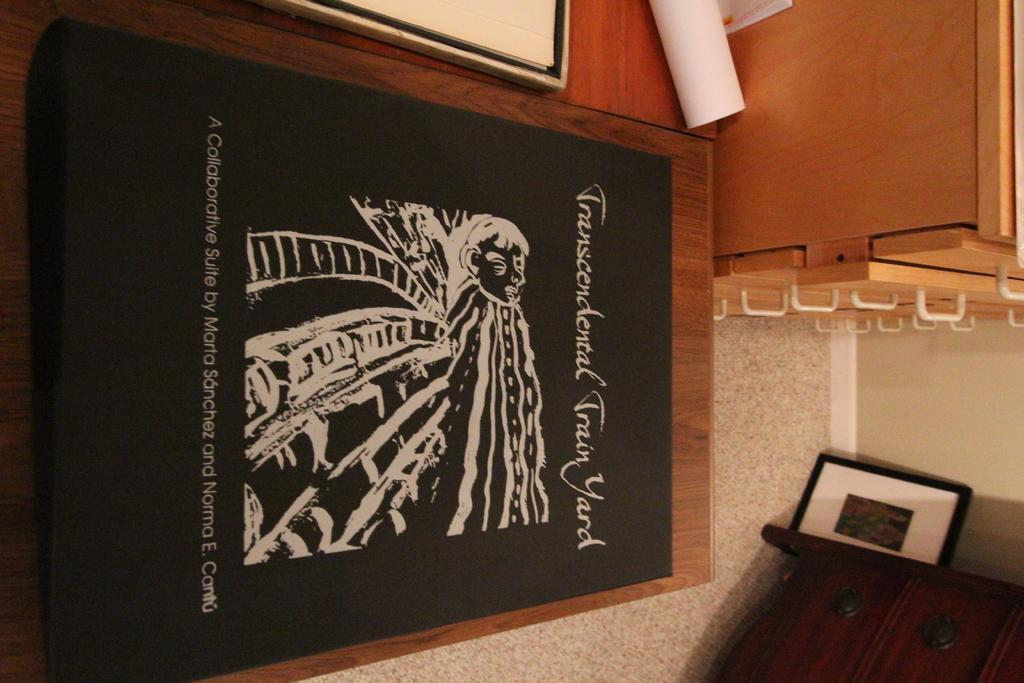What is the black object with text on it in the image? There is text on a black object in the image, but we cannot determine its exact nature from the given facts. What type of material are the wooden objects made of? The wooden objects in the image are made of wood. Can you describe the other objects in the image? Unfortunately, we cannot describe the other objects in the image, as the provided facts do not give us enough information about them. How many eyes can be seen on the pan in the image? There is no pan present in the image, and therefore no eyes can be seen on it. 